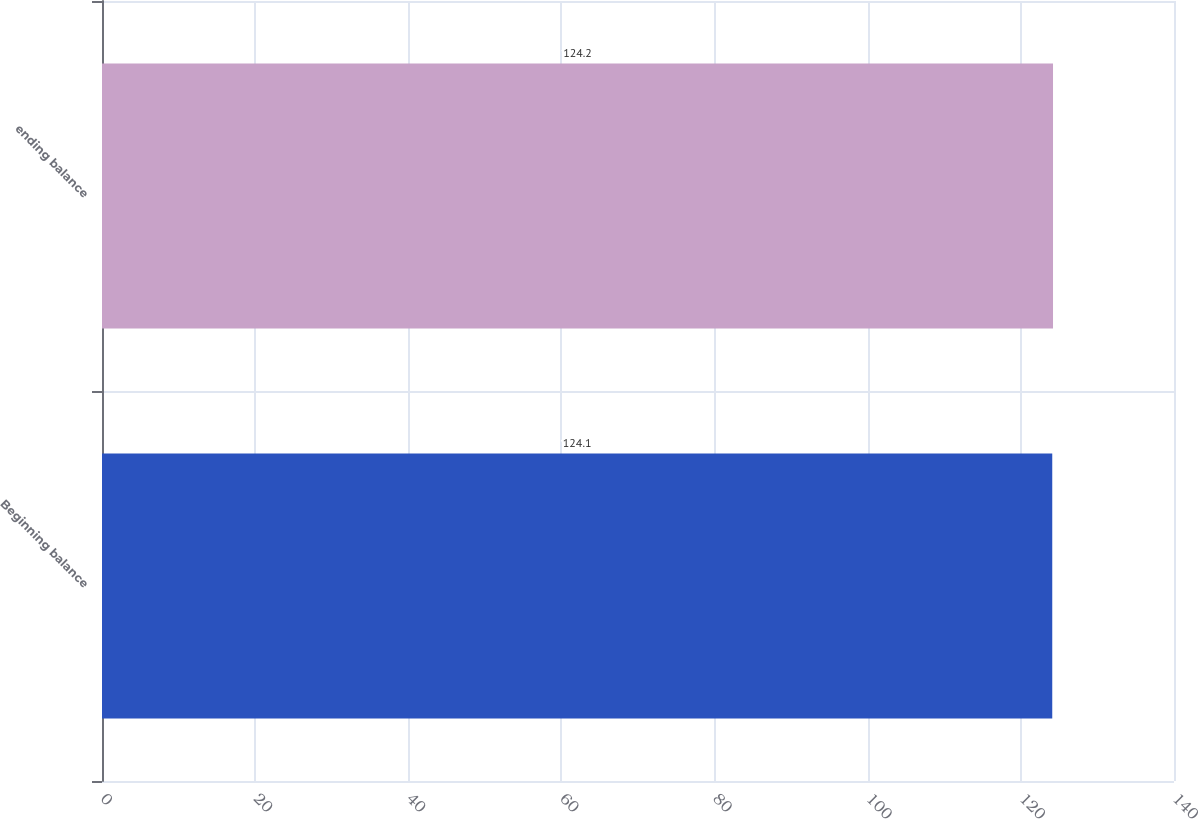<chart> <loc_0><loc_0><loc_500><loc_500><bar_chart><fcel>Beginning balance<fcel>ending balance<nl><fcel>124.1<fcel>124.2<nl></chart> 